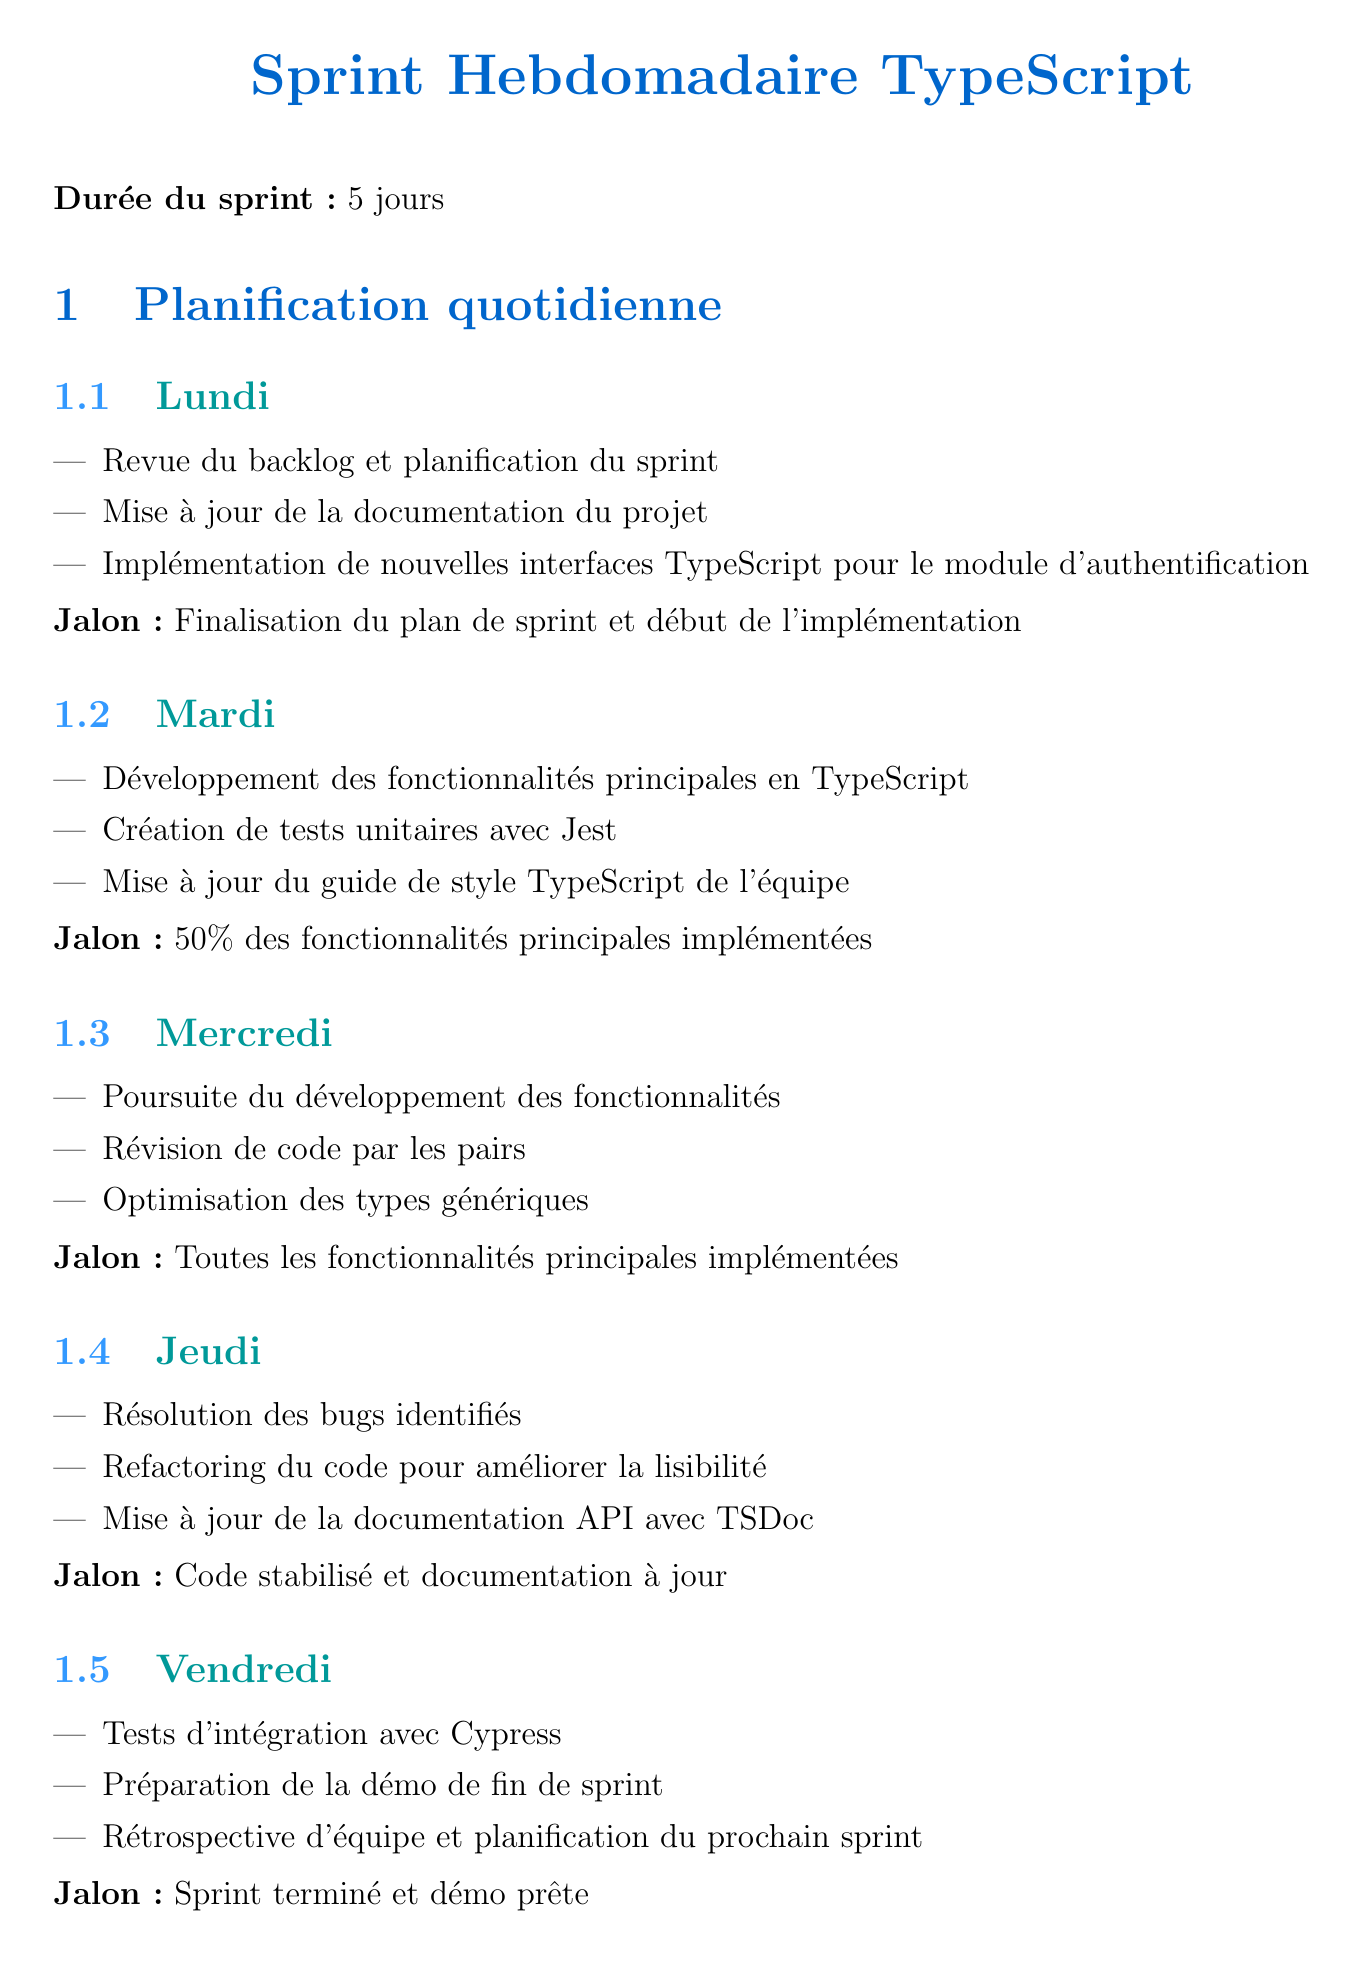Quel est le jour de début du sprint ? Le sprint commence le lundi, comme indiqué dans le document.
Answer: Lundi Quels outils sont utilisés pour le linting TypeScript ? Le document mentionne l'utilisation d'ESLint pour le linting TypeScript.
Answer: ESLint Quel jalon est atteint le mercredi ? Le jalon du mercredi est la finalisation de toutes les fonctionnalités principales implémentées.
Answer: Toutes les fonctionnalités principales implémentées Quel pourcentage des fonctionnalités principales est implémenté le mardi ? Le document précise que 50% des fonctionnalités principales sont implémentées le mardi.
Answer: 50% Combien de jours dure le sprint ? Le document indique que la durée du sprint est de 5 jours.
Answer: 5 jours Quels sont les bonnes pratiques mentionnées dans le document ? Les bonnes pratiques incluent l'utilisation de types stricts et d'interfaces pour des structures de données complexes.
Answer: Utiliser des types stricts et éviter 'any' Quel est l'objectif de la documentation concernant le README.md ? L'objectif est de maintenir un README.md à jour avec des instructions d'installation et de configuration.
Answer: Instructions d'installation et de configuration Quel type de tests est pratiqué le vendredi ? Le document mentionne des tests d'intégration effectués avec Cypress le vendredi.
Answer: Tests d'intégration avec Cypress Quel est le livre recommandé pour les ressources d'apprentissage ? Le livre recommandé dans les ressources d'apprentissage est "Effective TypeScript" par Dan Vanderkam.
Answer: Effective TypeScript 